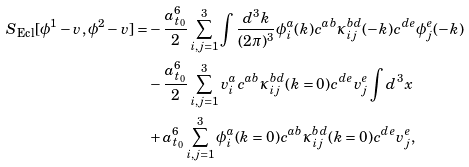<formula> <loc_0><loc_0><loc_500><loc_500>S _ { \text {Ecl} } [ \phi ^ { 1 } - v , \phi ^ { 2 } - v ] = & - \frac { a _ { t _ { 0 } } ^ { 6 } } { 2 } \sum ^ { 3 } _ { i , j = 1 } \int \frac { d ^ { 3 } k } { ( 2 \pi ) ^ { 3 } } \phi _ { i } ^ { a } ( { k } ) c ^ { a b } \kappa _ { i j } ^ { b d } ( - { k } ) c ^ { d e } \phi _ { j } ^ { e } ( - { k } ) \\ & - \frac { a _ { t _ { 0 } } ^ { 6 } } { 2 } \sum ^ { 3 } _ { i , j = 1 } v ^ { a } _ { i } c ^ { a b } \kappa ^ { b d } _ { i j } ( { k } = 0 ) c ^ { d e } v ^ { e } _ { j } \int d ^ { 3 } { x } \\ & + a _ { t _ { 0 } } ^ { 6 } \sum ^ { 3 } _ { i , j = 1 } \phi ^ { a } _ { i } ( { k } = 0 ) c ^ { a b } \kappa ^ { b d } _ { i j } ( { k } = 0 ) c ^ { d e } v ^ { e } _ { j } ,</formula> 